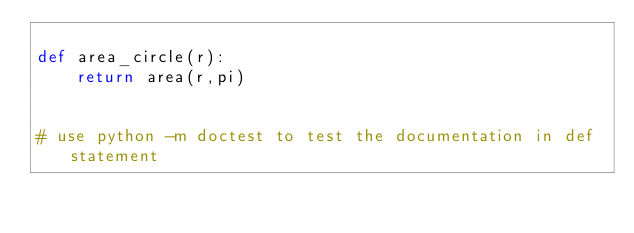<code> <loc_0><loc_0><loc_500><loc_500><_Python_>
def area_circle(r):
    return area(r,pi)


# use python -m doctest to test the documentation in def statement
</code> 